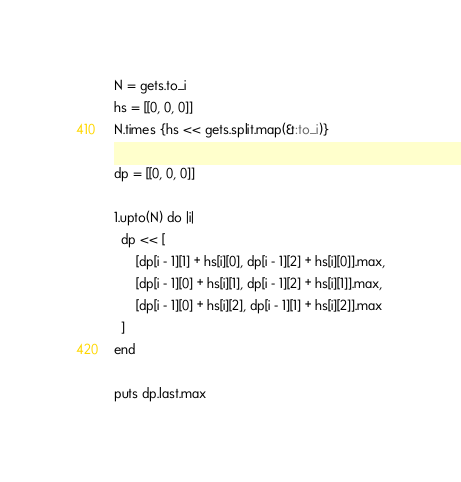<code> <loc_0><loc_0><loc_500><loc_500><_Ruby_>N = gets.to_i
hs = [[0, 0, 0]]
N.times {hs << gets.split.map(&:to_i)}

dp = [[0, 0, 0]]

1.upto(N) do |i|
  dp << [
      [dp[i - 1][1] + hs[i][0], dp[i - 1][2] + hs[i][0]].max,
      [dp[i - 1][0] + hs[i][1], dp[i - 1][2] + hs[i][1]].max,
      [dp[i - 1][0] + hs[i][2], dp[i - 1][1] + hs[i][2]].max
  ]
end

puts dp.last.max</code> 